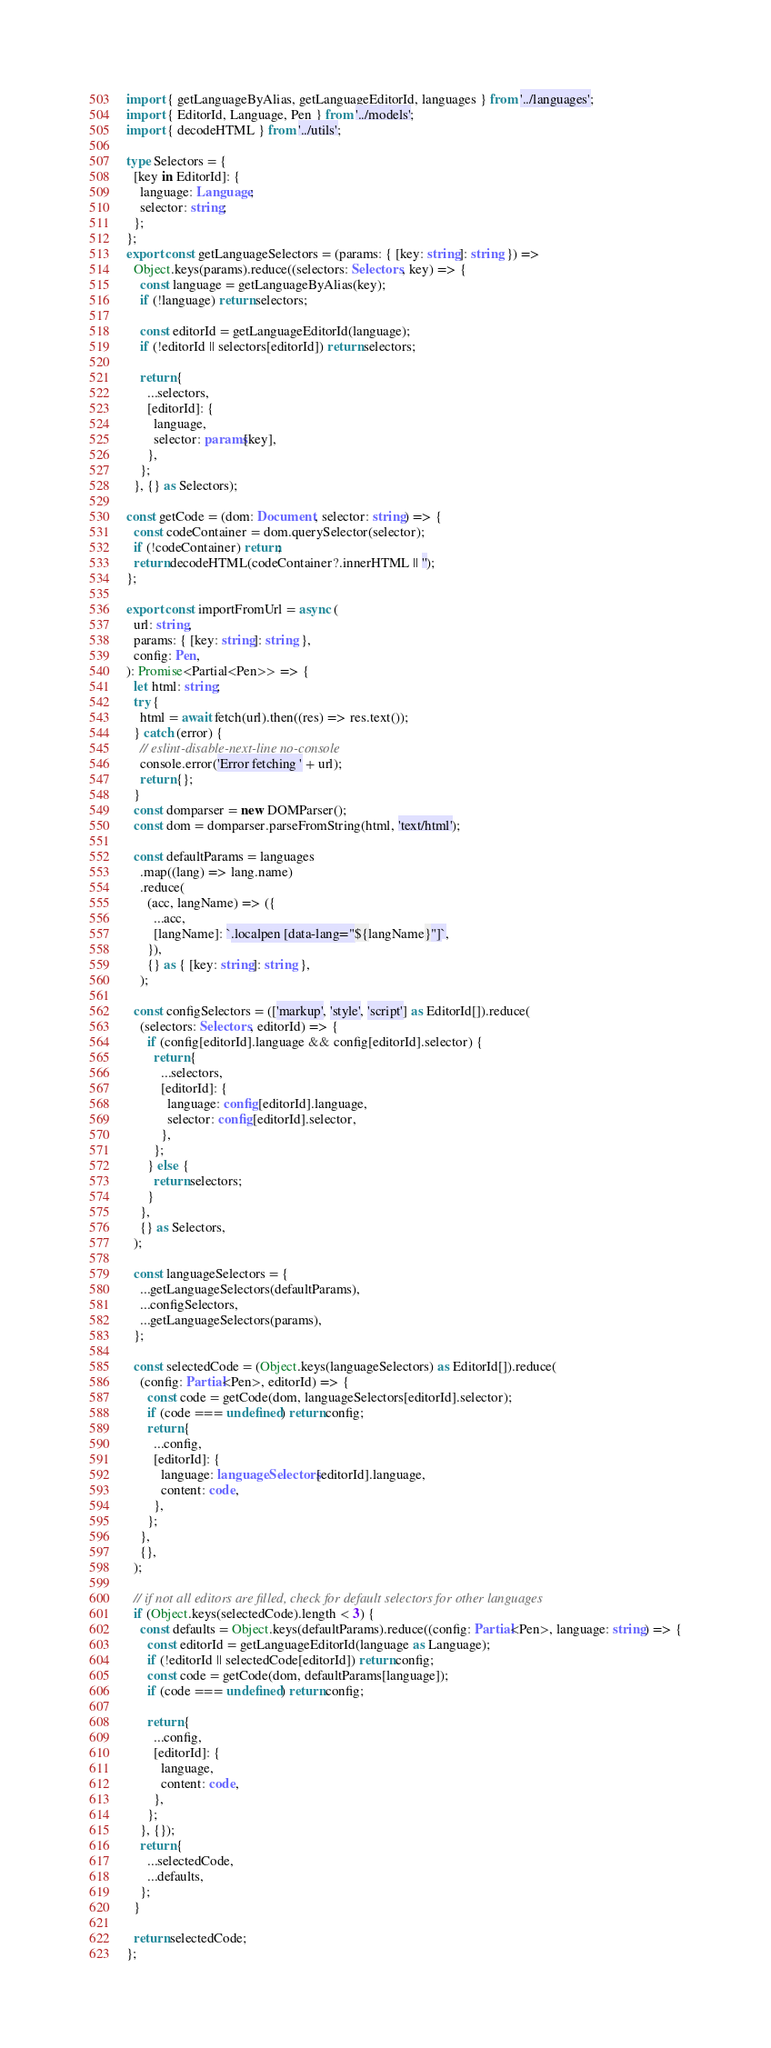Convert code to text. <code><loc_0><loc_0><loc_500><loc_500><_TypeScript_>import { getLanguageByAlias, getLanguageEditorId, languages } from '../languages';
import { EditorId, Language, Pen } from '../models';
import { decodeHTML } from '../utils';

type Selectors = {
  [key in EditorId]: {
    language: Language;
    selector: string;
  };
};
export const getLanguageSelectors = (params: { [key: string]: string }) =>
  Object.keys(params).reduce((selectors: Selectors, key) => {
    const language = getLanguageByAlias(key);
    if (!language) return selectors;

    const editorId = getLanguageEditorId(language);
    if (!editorId || selectors[editorId]) return selectors;

    return {
      ...selectors,
      [editorId]: {
        language,
        selector: params[key],
      },
    };
  }, {} as Selectors);

const getCode = (dom: Document, selector: string) => {
  const codeContainer = dom.querySelector(selector);
  if (!codeContainer) return;
  return decodeHTML(codeContainer?.innerHTML || '');
};

export const importFromUrl = async (
  url: string,
  params: { [key: string]: string },
  config: Pen,
): Promise<Partial<Pen>> => {
  let html: string;
  try {
    html = await fetch(url).then((res) => res.text());
  } catch (error) {
    // eslint-disable-next-line no-console
    console.error('Error fetching ' + url);
    return {};
  }
  const domparser = new DOMParser();
  const dom = domparser.parseFromString(html, 'text/html');

  const defaultParams = languages
    .map((lang) => lang.name)
    .reduce(
      (acc, langName) => ({
        ...acc,
        [langName]: `.localpen [data-lang="${langName}"]`,
      }),
      {} as { [key: string]: string },
    );

  const configSelectors = (['markup', 'style', 'script'] as EditorId[]).reduce(
    (selectors: Selectors, editorId) => {
      if (config[editorId].language && config[editorId].selector) {
        return {
          ...selectors,
          [editorId]: {
            language: config[editorId].language,
            selector: config[editorId].selector,
          },
        };
      } else {
        return selectors;
      }
    },
    {} as Selectors,
  );

  const languageSelectors = {
    ...getLanguageSelectors(defaultParams),
    ...configSelectors,
    ...getLanguageSelectors(params),
  };

  const selectedCode = (Object.keys(languageSelectors) as EditorId[]).reduce(
    (config: Partial<Pen>, editorId) => {
      const code = getCode(dom, languageSelectors[editorId].selector);
      if (code === undefined) return config;
      return {
        ...config,
        [editorId]: {
          language: languageSelectors[editorId].language,
          content: code,
        },
      };
    },
    {},
  );

  // if not all editors are filled, check for default selectors for other languages
  if (Object.keys(selectedCode).length < 3) {
    const defaults = Object.keys(defaultParams).reduce((config: Partial<Pen>, language: string) => {
      const editorId = getLanguageEditorId(language as Language);
      if (!editorId || selectedCode[editorId]) return config;
      const code = getCode(dom, defaultParams[language]);
      if (code === undefined) return config;

      return {
        ...config,
        [editorId]: {
          language,
          content: code,
        },
      };
    }, {});
    return {
      ...selectedCode,
      ...defaults,
    };
  }

  return selectedCode;
};
</code> 